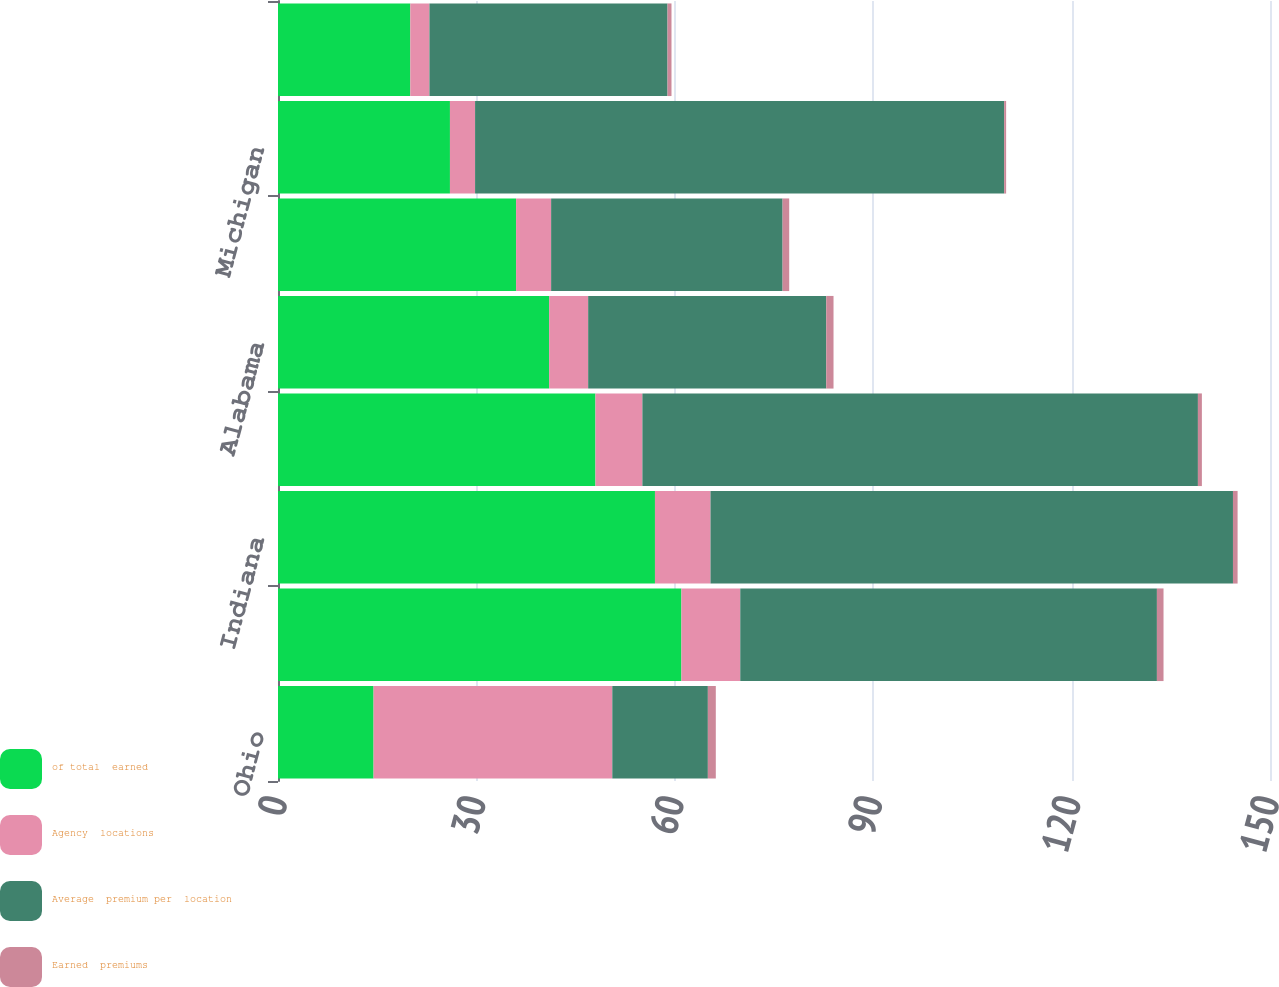<chart> <loc_0><loc_0><loc_500><loc_500><stacked_bar_chart><ecel><fcel>Ohio<fcel>Georgia<fcel>Indiana<fcel>Illinois<fcel>Alabama<fcel>Kentucky<fcel>Michigan<fcel>Tennessee<nl><fcel>of total  earned<fcel>14.45<fcel>61<fcel>57<fcel>48<fcel>41<fcel>36<fcel>26<fcel>20<nl><fcel>Agency  locations<fcel>36.1<fcel>8.9<fcel>8.4<fcel>7.1<fcel>5.9<fcel>5.3<fcel>3.8<fcel>2.9<nl><fcel>Average  premium per  location<fcel>14.45<fcel>63<fcel>79<fcel>84<fcel>36<fcel>35<fcel>80<fcel>36<nl><fcel>Earned  premiums<fcel>1.2<fcel>1<fcel>0.7<fcel>0.6<fcel>1.1<fcel>1<fcel>0.3<fcel>0.6<nl></chart> 